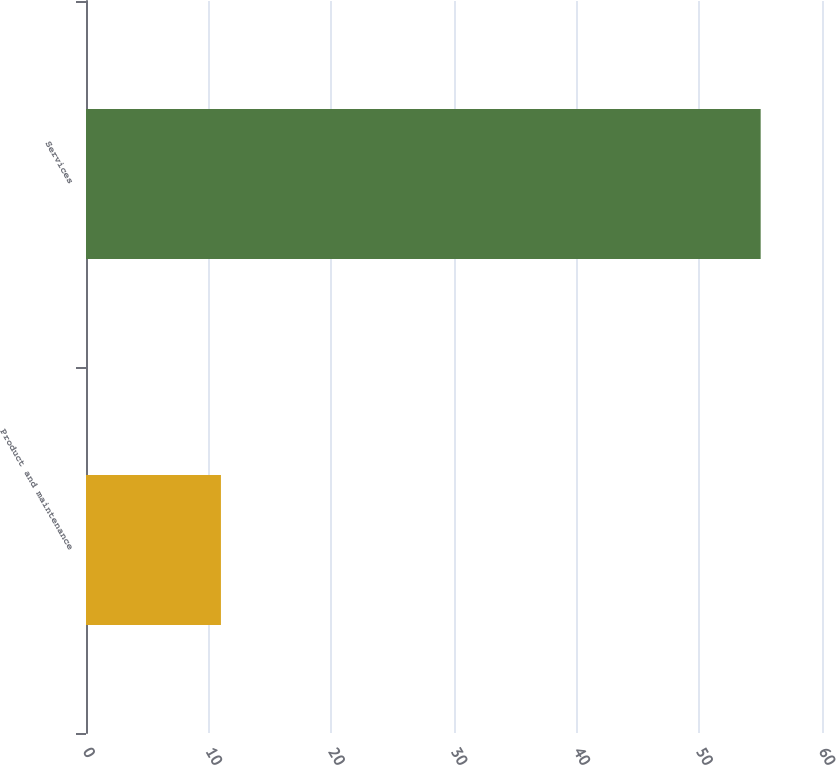Convert chart to OTSL. <chart><loc_0><loc_0><loc_500><loc_500><bar_chart><fcel>Product and maintenance<fcel>Services<nl><fcel>11<fcel>55<nl></chart> 